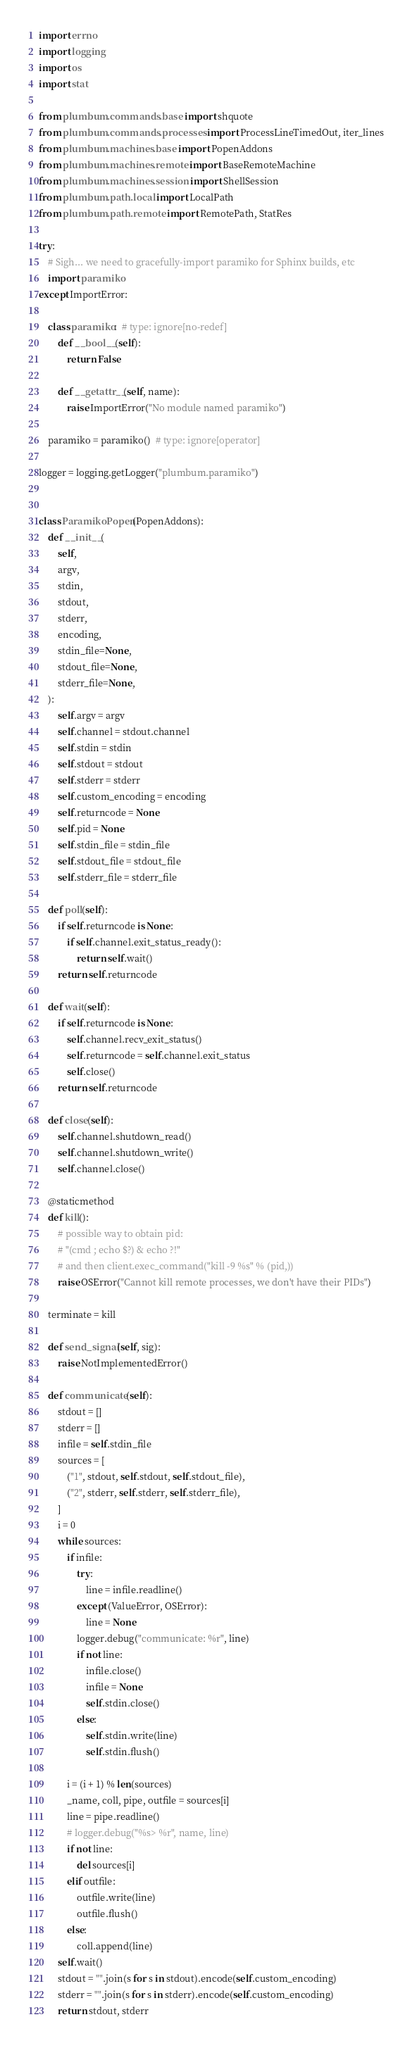<code> <loc_0><loc_0><loc_500><loc_500><_Python_>import errno
import logging
import os
import stat

from plumbum.commands.base import shquote
from plumbum.commands.processes import ProcessLineTimedOut, iter_lines
from plumbum.machines.base import PopenAddons
from plumbum.machines.remote import BaseRemoteMachine
from plumbum.machines.session import ShellSession
from plumbum.path.local import LocalPath
from plumbum.path.remote import RemotePath, StatRes

try:
    # Sigh... we need to gracefully-import paramiko for Sphinx builds, etc
    import paramiko
except ImportError:

    class paramiko:  # type: ignore[no-redef]
        def __bool__(self):
            return False

        def __getattr__(self, name):
            raise ImportError("No module named paramiko")

    paramiko = paramiko()  # type: ignore[operator]

logger = logging.getLogger("plumbum.paramiko")


class ParamikoPopen(PopenAddons):
    def __init__(
        self,
        argv,
        stdin,
        stdout,
        stderr,
        encoding,
        stdin_file=None,
        stdout_file=None,
        stderr_file=None,
    ):
        self.argv = argv
        self.channel = stdout.channel
        self.stdin = stdin
        self.stdout = stdout
        self.stderr = stderr
        self.custom_encoding = encoding
        self.returncode = None
        self.pid = None
        self.stdin_file = stdin_file
        self.stdout_file = stdout_file
        self.stderr_file = stderr_file

    def poll(self):
        if self.returncode is None:
            if self.channel.exit_status_ready():
                return self.wait()
        return self.returncode

    def wait(self):
        if self.returncode is None:
            self.channel.recv_exit_status()
            self.returncode = self.channel.exit_status
            self.close()
        return self.returncode

    def close(self):
        self.channel.shutdown_read()
        self.channel.shutdown_write()
        self.channel.close()

    @staticmethod
    def kill():
        # possible way to obtain pid:
        # "(cmd ; echo $?) & echo ?!"
        # and then client.exec_command("kill -9 %s" % (pid,))
        raise OSError("Cannot kill remote processes, we don't have their PIDs")

    terminate = kill

    def send_signal(self, sig):
        raise NotImplementedError()

    def communicate(self):
        stdout = []
        stderr = []
        infile = self.stdin_file
        sources = [
            ("1", stdout, self.stdout, self.stdout_file),
            ("2", stderr, self.stderr, self.stderr_file),
        ]
        i = 0
        while sources:
            if infile:
                try:
                    line = infile.readline()
                except (ValueError, OSError):
                    line = None
                logger.debug("communicate: %r", line)
                if not line:
                    infile.close()
                    infile = None
                    self.stdin.close()
                else:
                    self.stdin.write(line)
                    self.stdin.flush()

            i = (i + 1) % len(sources)
            _name, coll, pipe, outfile = sources[i]
            line = pipe.readline()
            # logger.debug("%s> %r", name, line)
            if not line:
                del sources[i]
            elif outfile:
                outfile.write(line)
                outfile.flush()
            else:
                coll.append(line)
        self.wait()
        stdout = "".join(s for s in stdout).encode(self.custom_encoding)
        stderr = "".join(s for s in stderr).encode(self.custom_encoding)
        return stdout, stderr
</code> 